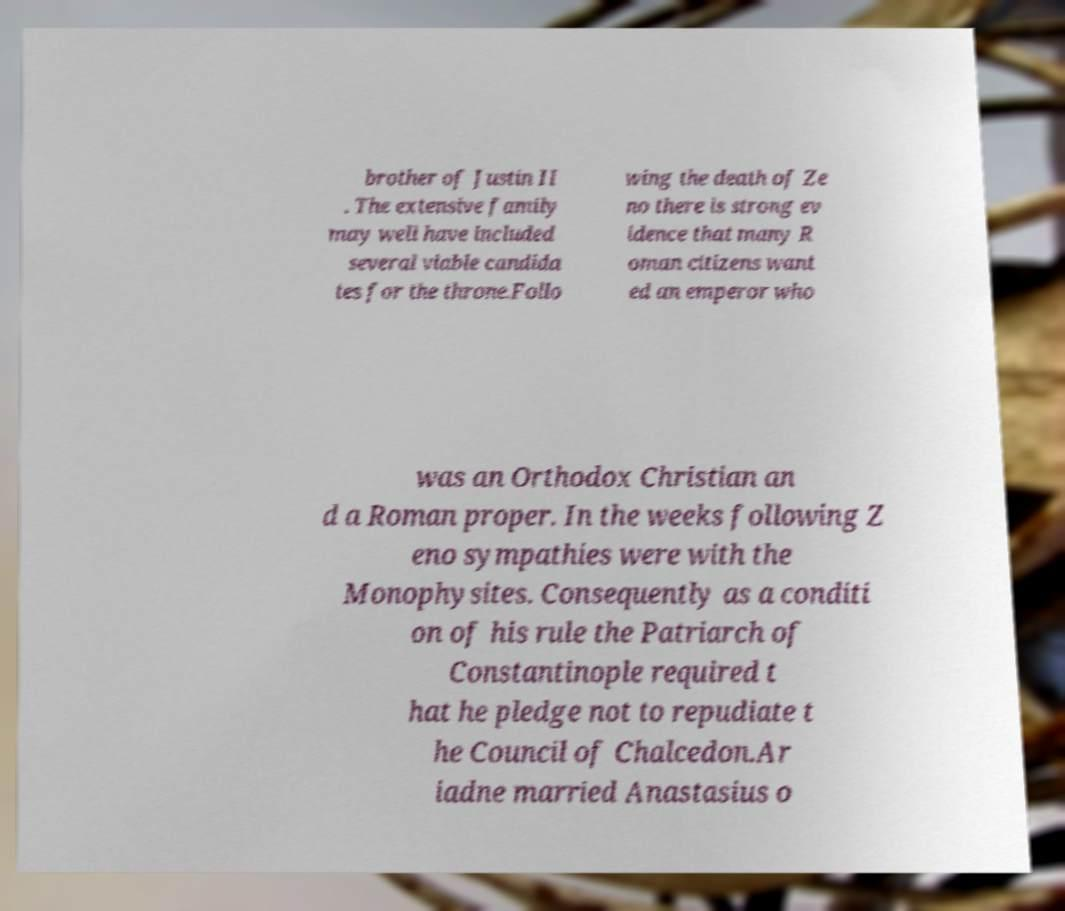For documentation purposes, I need the text within this image transcribed. Could you provide that? brother of Justin II . The extensive family may well have included several viable candida tes for the throne.Follo wing the death of Ze no there is strong ev idence that many R oman citizens want ed an emperor who was an Orthodox Christian an d a Roman proper. In the weeks following Z eno sympathies were with the Monophysites. Consequently as a conditi on of his rule the Patriarch of Constantinople required t hat he pledge not to repudiate t he Council of Chalcedon.Ar iadne married Anastasius o 